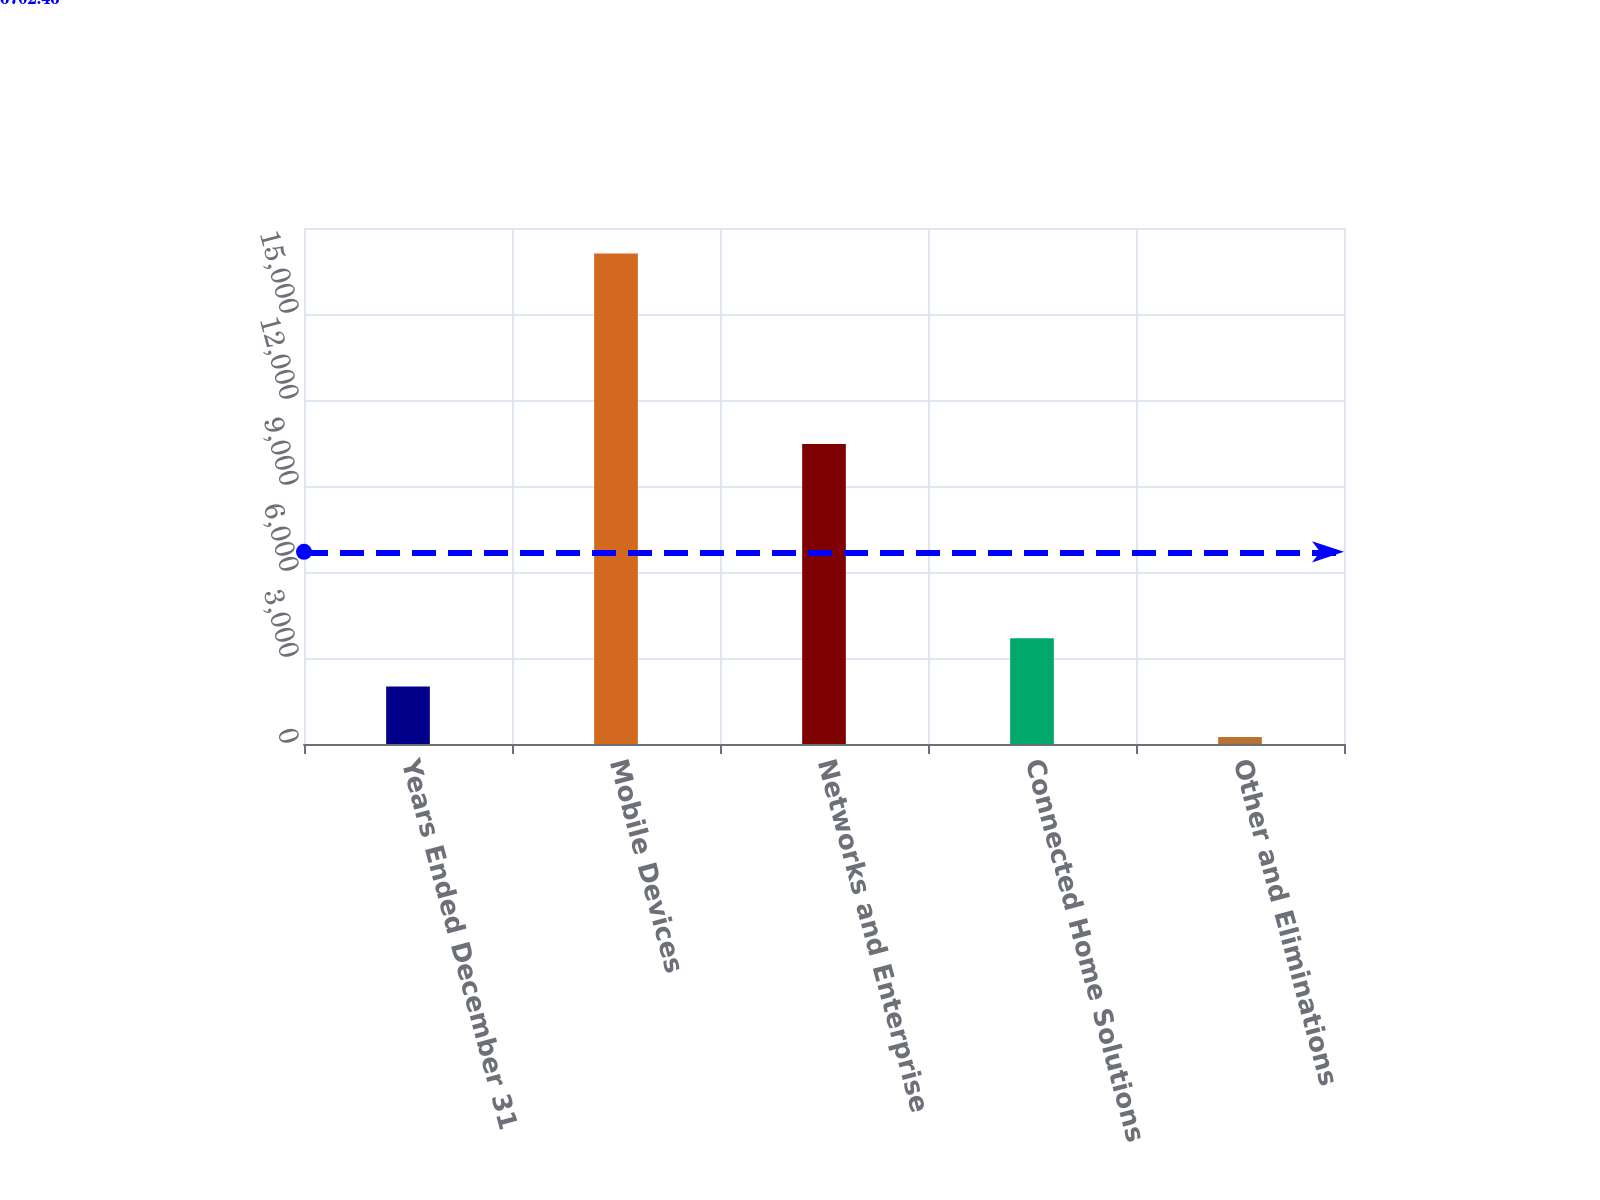<chart> <loc_0><loc_0><loc_500><loc_500><bar_chart><fcel>Years Ended December 31<fcel>Mobile Devices<fcel>Networks and Enterprise<fcel>Connected Home Solutions<fcel>Other and Eliminations<nl><fcel>2004<fcel>17108<fcel>10465<fcel>3690.3<fcel>245<nl></chart> 